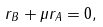<formula> <loc_0><loc_0><loc_500><loc_500>r _ { B } + \mu r _ { A } = 0 ,</formula> 